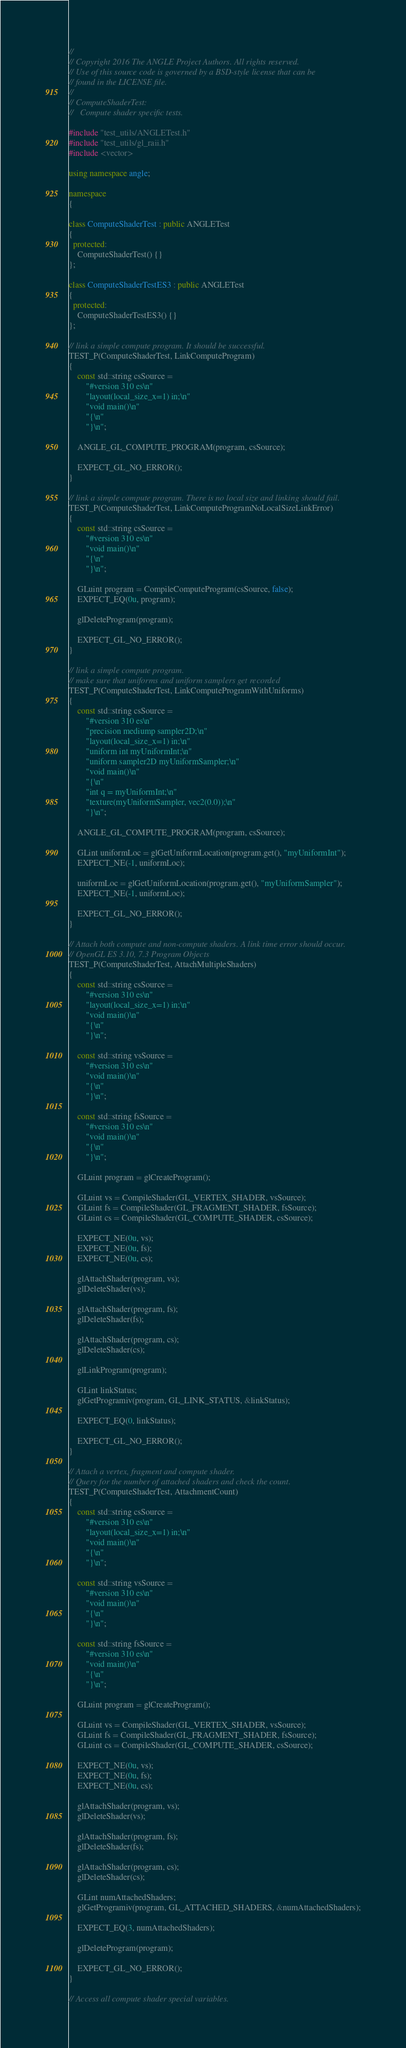Convert code to text. <code><loc_0><loc_0><loc_500><loc_500><_C++_>//
// Copyright 2016 The ANGLE Project Authors. All rights reserved.
// Use of this source code is governed by a BSD-style license that can be
// found in the LICENSE file.
//
// ComputeShaderTest:
//   Compute shader specific tests.

#include "test_utils/ANGLETest.h"
#include "test_utils/gl_raii.h"
#include <vector>

using namespace angle;

namespace
{

class ComputeShaderTest : public ANGLETest
{
  protected:
    ComputeShaderTest() {}
};

class ComputeShaderTestES3 : public ANGLETest
{
  protected:
    ComputeShaderTestES3() {}
};

// link a simple compute program. It should be successful.
TEST_P(ComputeShaderTest, LinkComputeProgram)
{
    const std::string csSource =
        "#version 310 es\n"
        "layout(local_size_x=1) in;\n"
        "void main()\n"
        "{\n"
        "}\n";

    ANGLE_GL_COMPUTE_PROGRAM(program, csSource);

    EXPECT_GL_NO_ERROR();
}

// link a simple compute program. There is no local size and linking should fail.
TEST_P(ComputeShaderTest, LinkComputeProgramNoLocalSizeLinkError)
{
    const std::string csSource =
        "#version 310 es\n"
        "void main()\n"
        "{\n"
        "}\n";

    GLuint program = CompileComputeProgram(csSource, false);
    EXPECT_EQ(0u, program);

    glDeleteProgram(program);

    EXPECT_GL_NO_ERROR();
}

// link a simple compute program.
// make sure that uniforms and uniform samplers get recorded
TEST_P(ComputeShaderTest, LinkComputeProgramWithUniforms)
{
    const std::string csSource =
        "#version 310 es\n"
        "precision mediump sampler2D;\n"
        "layout(local_size_x=1) in;\n"
        "uniform int myUniformInt;\n"
        "uniform sampler2D myUniformSampler;\n"
        "void main()\n"
        "{\n"
        "int q = myUniformInt;\n"
        "texture(myUniformSampler, vec2(0.0));\n"
        "}\n";

    ANGLE_GL_COMPUTE_PROGRAM(program, csSource);

    GLint uniformLoc = glGetUniformLocation(program.get(), "myUniformInt");
    EXPECT_NE(-1, uniformLoc);

    uniformLoc = glGetUniformLocation(program.get(), "myUniformSampler");
    EXPECT_NE(-1, uniformLoc);

    EXPECT_GL_NO_ERROR();
}

// Attach both compute and non-compute shaders. A link time error should occur.
// OpenGL ES 3.10, 7.3 Program Objects
TEST_P(ComputeShaderTest, AttachMultipleShaders)
{
    const std::string csSource =
        "#version 310 es\n"
        "layout(local_size_x=1) in;\n"
        "void main()\n"
        "{\n"
        "}\n";

    const std::string vsSource =
        "#version 310 es\n"
        "void main()\n"
        "{\n"
        "}\n";

    const std::string fsSource =
        "#version 310 es\n"
        "void main()\n"
        "{\n"
        "}\n";

    GLuint program = glCreateProgram();

    GLuint vs = CompileShader(GL_VERTEX_SHADER, vsSource);
    GLuint fs = CompileShader(GL_FRAGMENT_SHADER, fsSource);
    GLuint cs = CompileShader(GL_COMPUTE_SHADER, csSource);

    EXPECT_NE(0u, vs);
    EXPECT_NE(0u, fs);
    EXPECT_NE(0u, cs);

    glAttachShader(program, vs);
    glDeleteShader(vs);

    glAttachShader(program, fs);
    glDeleteShader(fs);

    glAttachShader(program, cs);
    glDeleteShader(cs);

    glLinkProgram(program);

    GLint linkStatus;
    glGetProgramiv(program, GL_LINK_STATUS, &linkStatus);

    EXPECT_EQ(0, linkStatus);

    EXPECT_GL_NO_ERROR();
}

// Attach a vertex, fragment and compute shader.
// Query for the number of attached shaders and check the count.
TEST_P(ComputeShaderTest, AttachmentCount)
{
    const std::string csSource =
        "#version 310 es\n"
        "layout(local_size_x=1) in;\n"
        "void main()\n"
        "{\n"
        "}\n";

    const std::string vsSource =
        "#version 310 es\n"
        "void main()\n"
        "{\n"
        "}\n";

    const std::string fsSource =
        "#version 310 es\n"
        "void main()\n"
        "{\n"
        "}\n";

    GLuint program = glCreateProgram();

    GLuint vs = CompileShader(GL_VERTEX_SHADER, vsSource);
    GLuint fs = CompileShader(GL_FRAGMENT_SHADER, fsSource);
    GLuint cs = CompileShader(GL_COMPUTE_SHADER, csSource);

    EXPECT_NE(0u, vs);
    EXPECT_NE(0u, fs);
    EXPECT_NE(0u, cs);

    glAttachShader(program, vs);
    glDeleteShader(vs);

    glAttachShader(program, fs);
    glDeleteShader(fs);

    glAttachShader(program, cs);
    glDeleteShader(cs);

    GLint numAttachedShaders;
    glGetProgramiv(program, GL_ATTACHED_SHADERS, &numAttachedShaders);

    EXPECT_EQ(3, numAttachedShaders);

    glDeleteProgram(program);

    EXPECT_GL_NO_ERROR();
}

// Access all compute shader special variables.</code> 